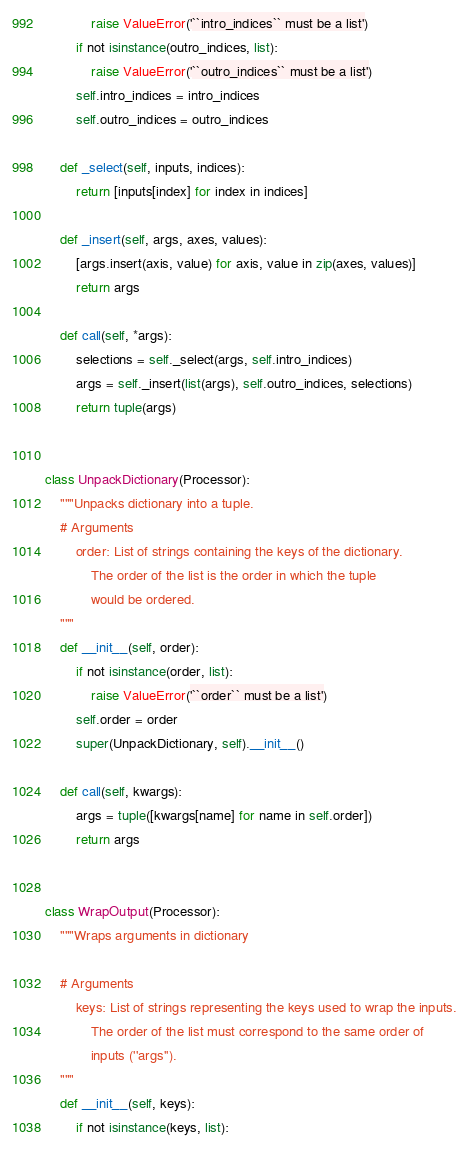<code> <loc_0><loc_0><loc_500><loc_500><_Python_>            raise ValueError('``intro_indices`` must be a list')
        if not isinstance(outro_indices, list):
            raise ValueError('``outro_indices`` must be a list')
        self.intro_indices = intro_indices
        self.outro_indices = outro_indices

    def _select(self, inputs, indices):
        return [inputs[index] for index in indices]

    def _insert(self, args, axes, values):
        [args.insert(axis, value) for axis, value in zip(axes, values)]
        return args

    def call(self, *args):
        selections = self._select(args, self.intro_indices)
        args = self._insert(list(args), self.outro_indices, selections)
        return tuple(args)


class UnpackDictionary(Processor):
    """Unpacks dictionary into a tuple.
    # Arguments
        order: List of strings containing the keys of the dictionary.
            The order of the list is the order in which the tuple
            would be ordered.
    """
    def __init__(self, order):
        if not isinstance(order, list):
            raise ValueError('``order`` must be a list')
        self.order = order
        super(UnpackDictionary, self).__init__()

    def call(self, kwargs):
        args = tuple([kwargs[name] for name in self.order])
        return args


class WrapOutput(Processor):
    """Wraps arguments in dictionary

    # Arguments
        keys: List of strings representing the keys used to wrap the inputs.
            The order of the list must correspond to the same order of
            inputs (''args'').
    """
    def __init__(self, keys):
        if not isinstance(keys, list):</code> 